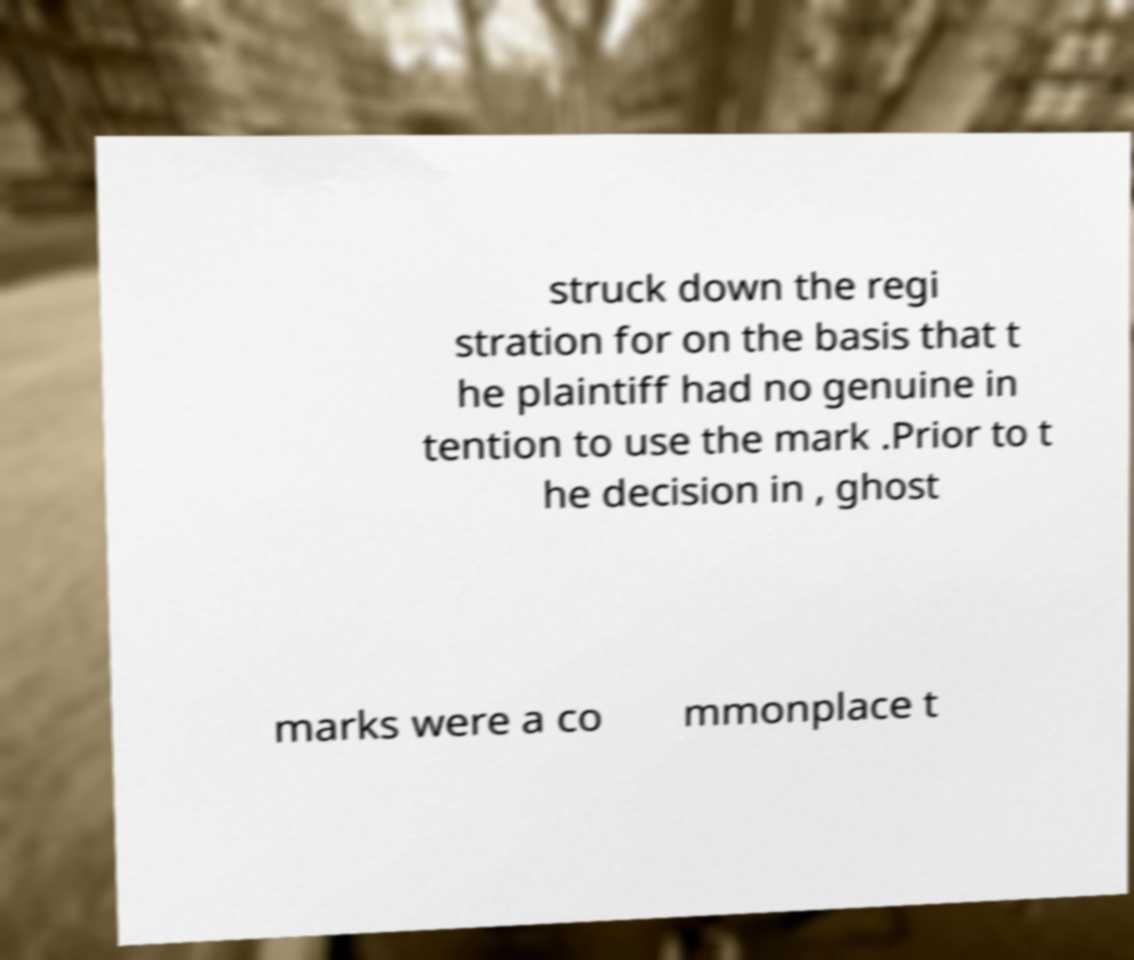There's text embedded in this image that I need extracted. Can you transcribe it verbatim? struck down the regi stration for on the basis that t he plaintiff had no genuine in tention to use the mark .Prior to t he decision in , ghost marks were a co mmonplace t 